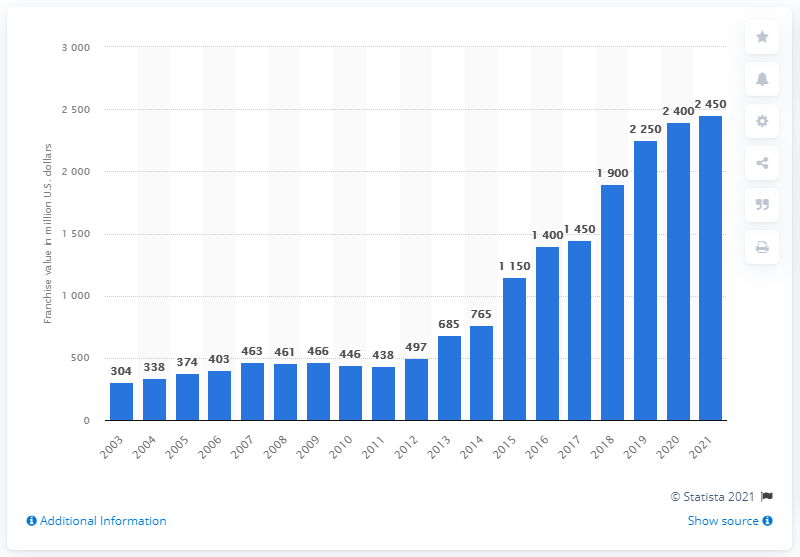Specify some key components in this picture. The estimated value of the Dallas Mavericks franchise in 2021 was 2,450. 